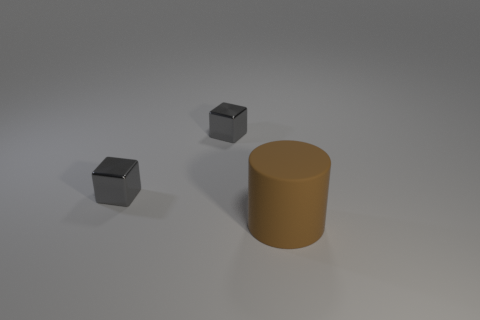How many cylinders are either large brown matte things or small gray things?
Give a very brief answer. 1. The matte object has what size?
Give a very brief answer. Large. The big thing has what shape?
Your answer should be compact. Cylinder. How many other things are the same size as the cylinder?
Your answer should be compact. 0. Are there the same number of tiny gray metal things that are in front of the big brown cylinder and rubber things?
Your answer should be very brief. No. The big matte cylinder has what color?
Offer a terse response. Brown. What number of other objects are there of the same shape as the big rubber thing?
Keep it short and to the point. 0. What is the brown object made of?
Your answer should be compact. Rubber. Is there any other thing that has the same material as the cylinder?
Offer a terse response. No. Is the number of brown matte things to the right of the big brown cylinder greater than the number of big brown objects?
Your answer should be very brief. No. 